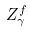<formula> <loc_0><loc_0><loc_500><loc_500>Z _ { \gamma } ^ { f }</formula> 